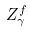<formula> <loc_0><loc_0><loc_500><loc_500>Z _ { \gamma } ^ { f }</formula> 